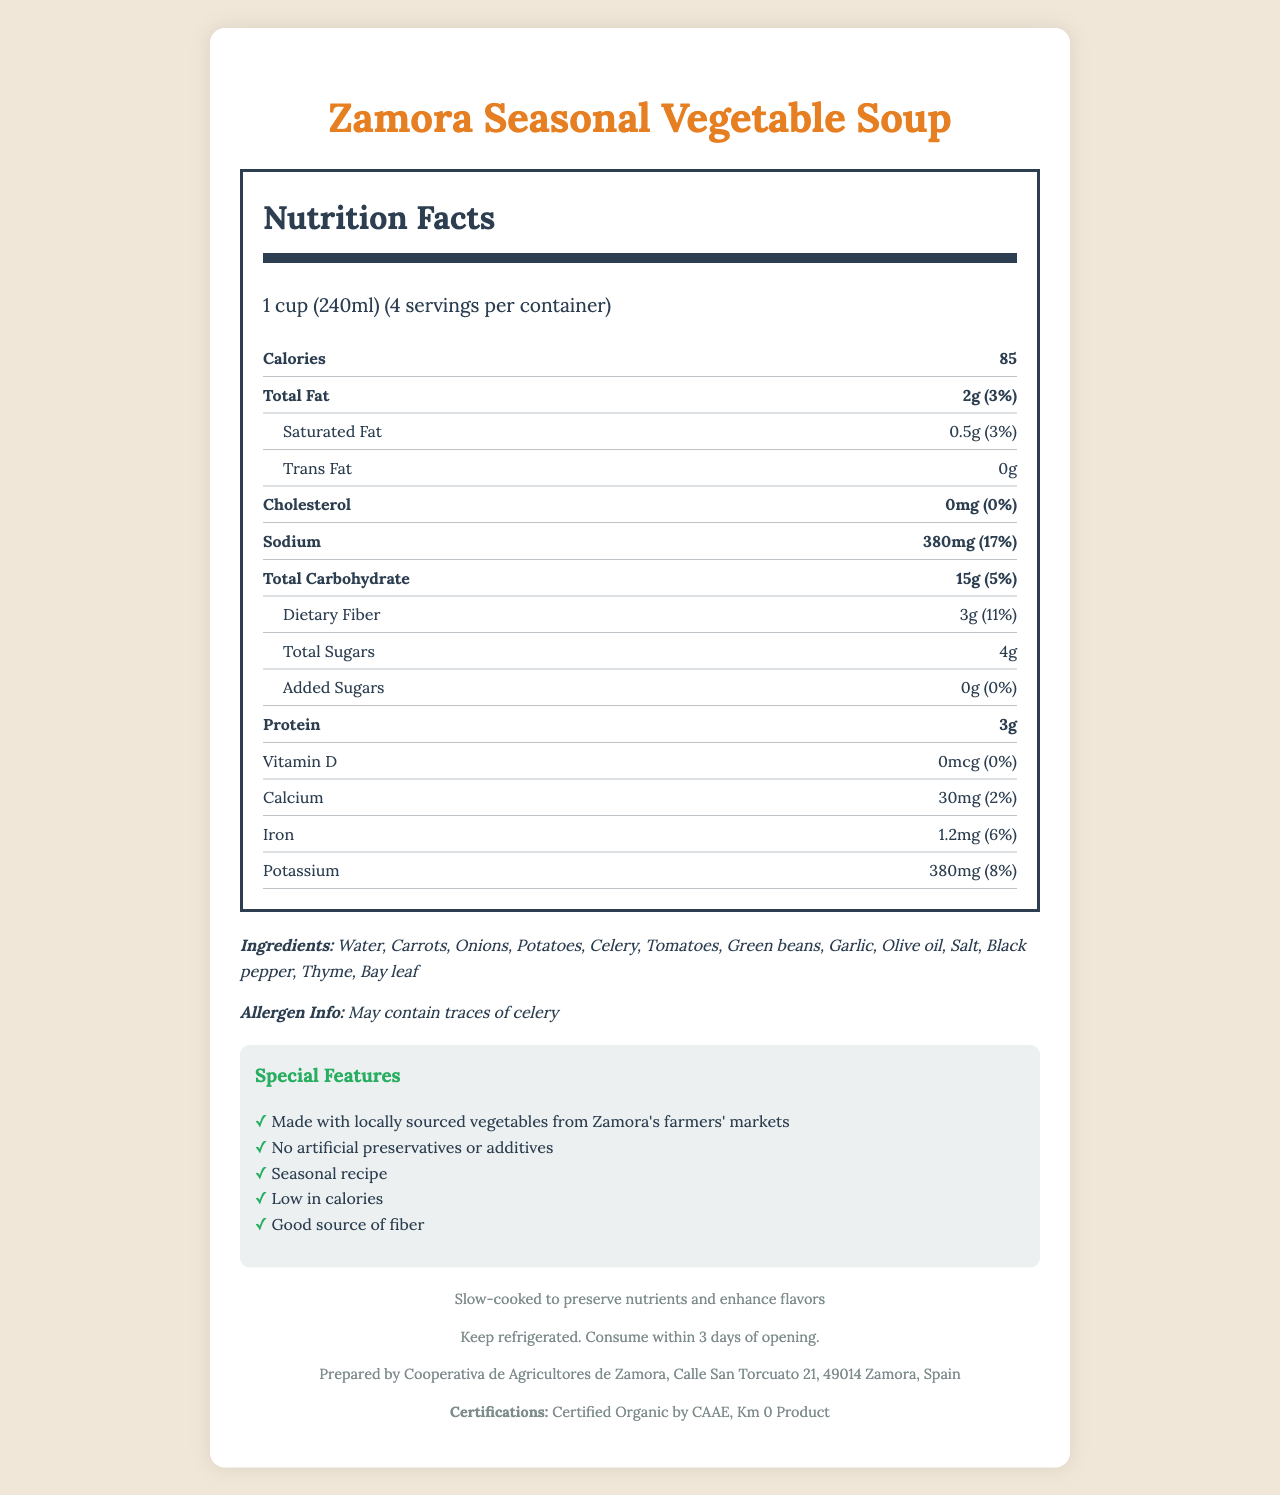what is the serving size? The serving size is clearly listed on the document as "1 cup (240ml)."
Answer: 1 cup (240ml) what is the total fat content per serving? The Total Fat content per serving is printed as "2g" on the document.
Answer: 2g how many servings are there per container? The document mentions that there are 4 servings per container.
Answer: 4 how much dietary fiber is in each serving? The dietary fiber content is listed as "3g" per serving in the document.
Answer: 3g how many calories are there per serving? The document states that there are 85 calories per serving.
Answer: 85 calories does the soup contain any added sugars? The document lists the amount of added sugars as "0g" and the daily value as "0%."
Answer: No what is the sodium content in one serving of soup? Sodium content is mentioned as "380mg" per serving in the document.
Answer: 380mg how many preparation methods for the soup are displayed? The document mentions only one preparation method: "Slow-cooked to preserve nutrients and enhance flavors."
Answer: 1 which of the following special features is NOT listed in the document? A. Good source of fiber B. Gluten-free C. Low in calories D. No artificial preservatives or additives The document lists "Good source of fiber," "Low in calories," and "No artificial preservatives or additives," but does not mention "Gluten-free."
Answer: B what is the main idea of this document? The document mainly presents detailed nutritional information about the Zamora Seasonal Vegetable Soup, including its ingredients, allergen info, special features, preparation method, storage instructions, manufacturer info, and certifications.
Answer: It provides nutritional information about Zamora Seasonal Vegetable Soup. how much calcium does this soup provide per serving? The document clearly indicates that there are 30mg of calcium per serving.
Answer: 30mg which ingredient is explicitly mentioned as a potential allergen? A. Garlic B. Celery C. Thyme The document states that it may contain traces of celery.
Answer: B is this soup suitable for someone trying to avoid cholesterol? The document lists the cholesterol content as "0mg," making it suitable for someone avoiding cholesterol.
Answer: Yes where is this soup manufactured? The document provides the manufacturer's information as “Cooperativa de Agricultores de Zamora, Calle San Torcuato 21, 49014 Zamora, Spain.”
Answer: Cooperativa de Agricultores de Zamora, Calle San Torcuato 21, 49014 Zamora, Spain how long should the soup be consumed after opening? The storage instruction states, "Consume within 3 days of opening."
Answer: Within 3 days can it be determined if the soup is vegan? The document does not provide information regarding whether the soup is vegan.
Answer: Not enough information what certifications does the soup have? The document lists the certifications as "Certified Organic by CAAE" and "Km 0 Product."
Answer: Certified Organic by CAAE, Km 0 Product 